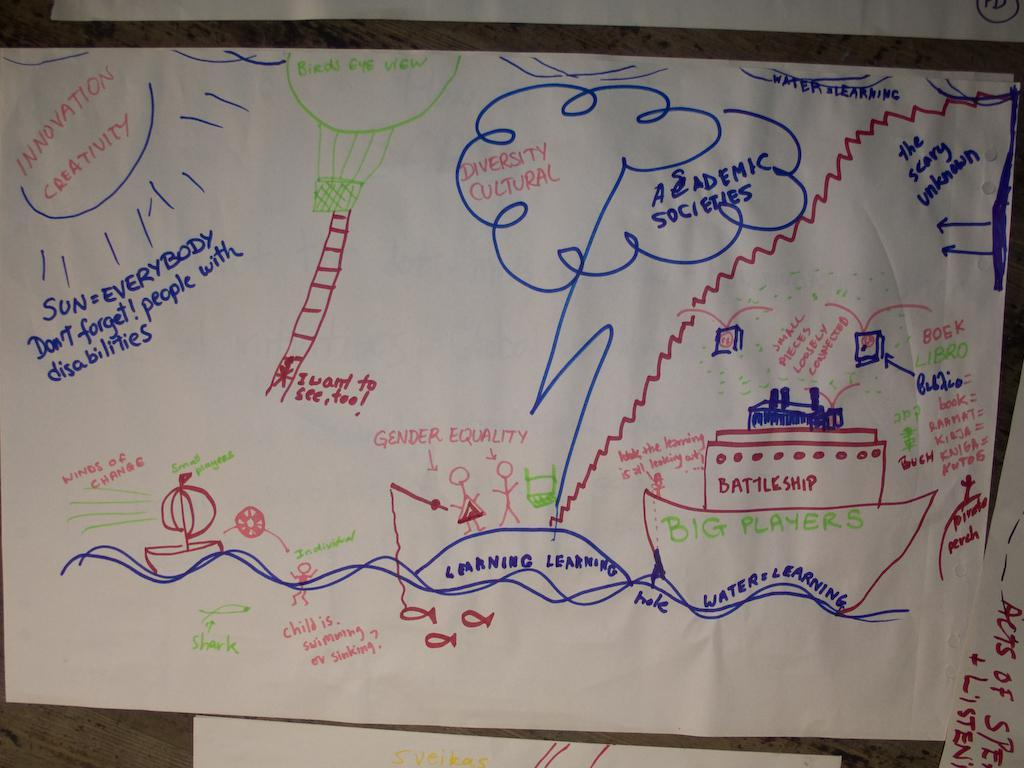<image>
Offer a succinct explanation of the picture presented. Someone has written "innovation creativity" on the sun in a drawing. 